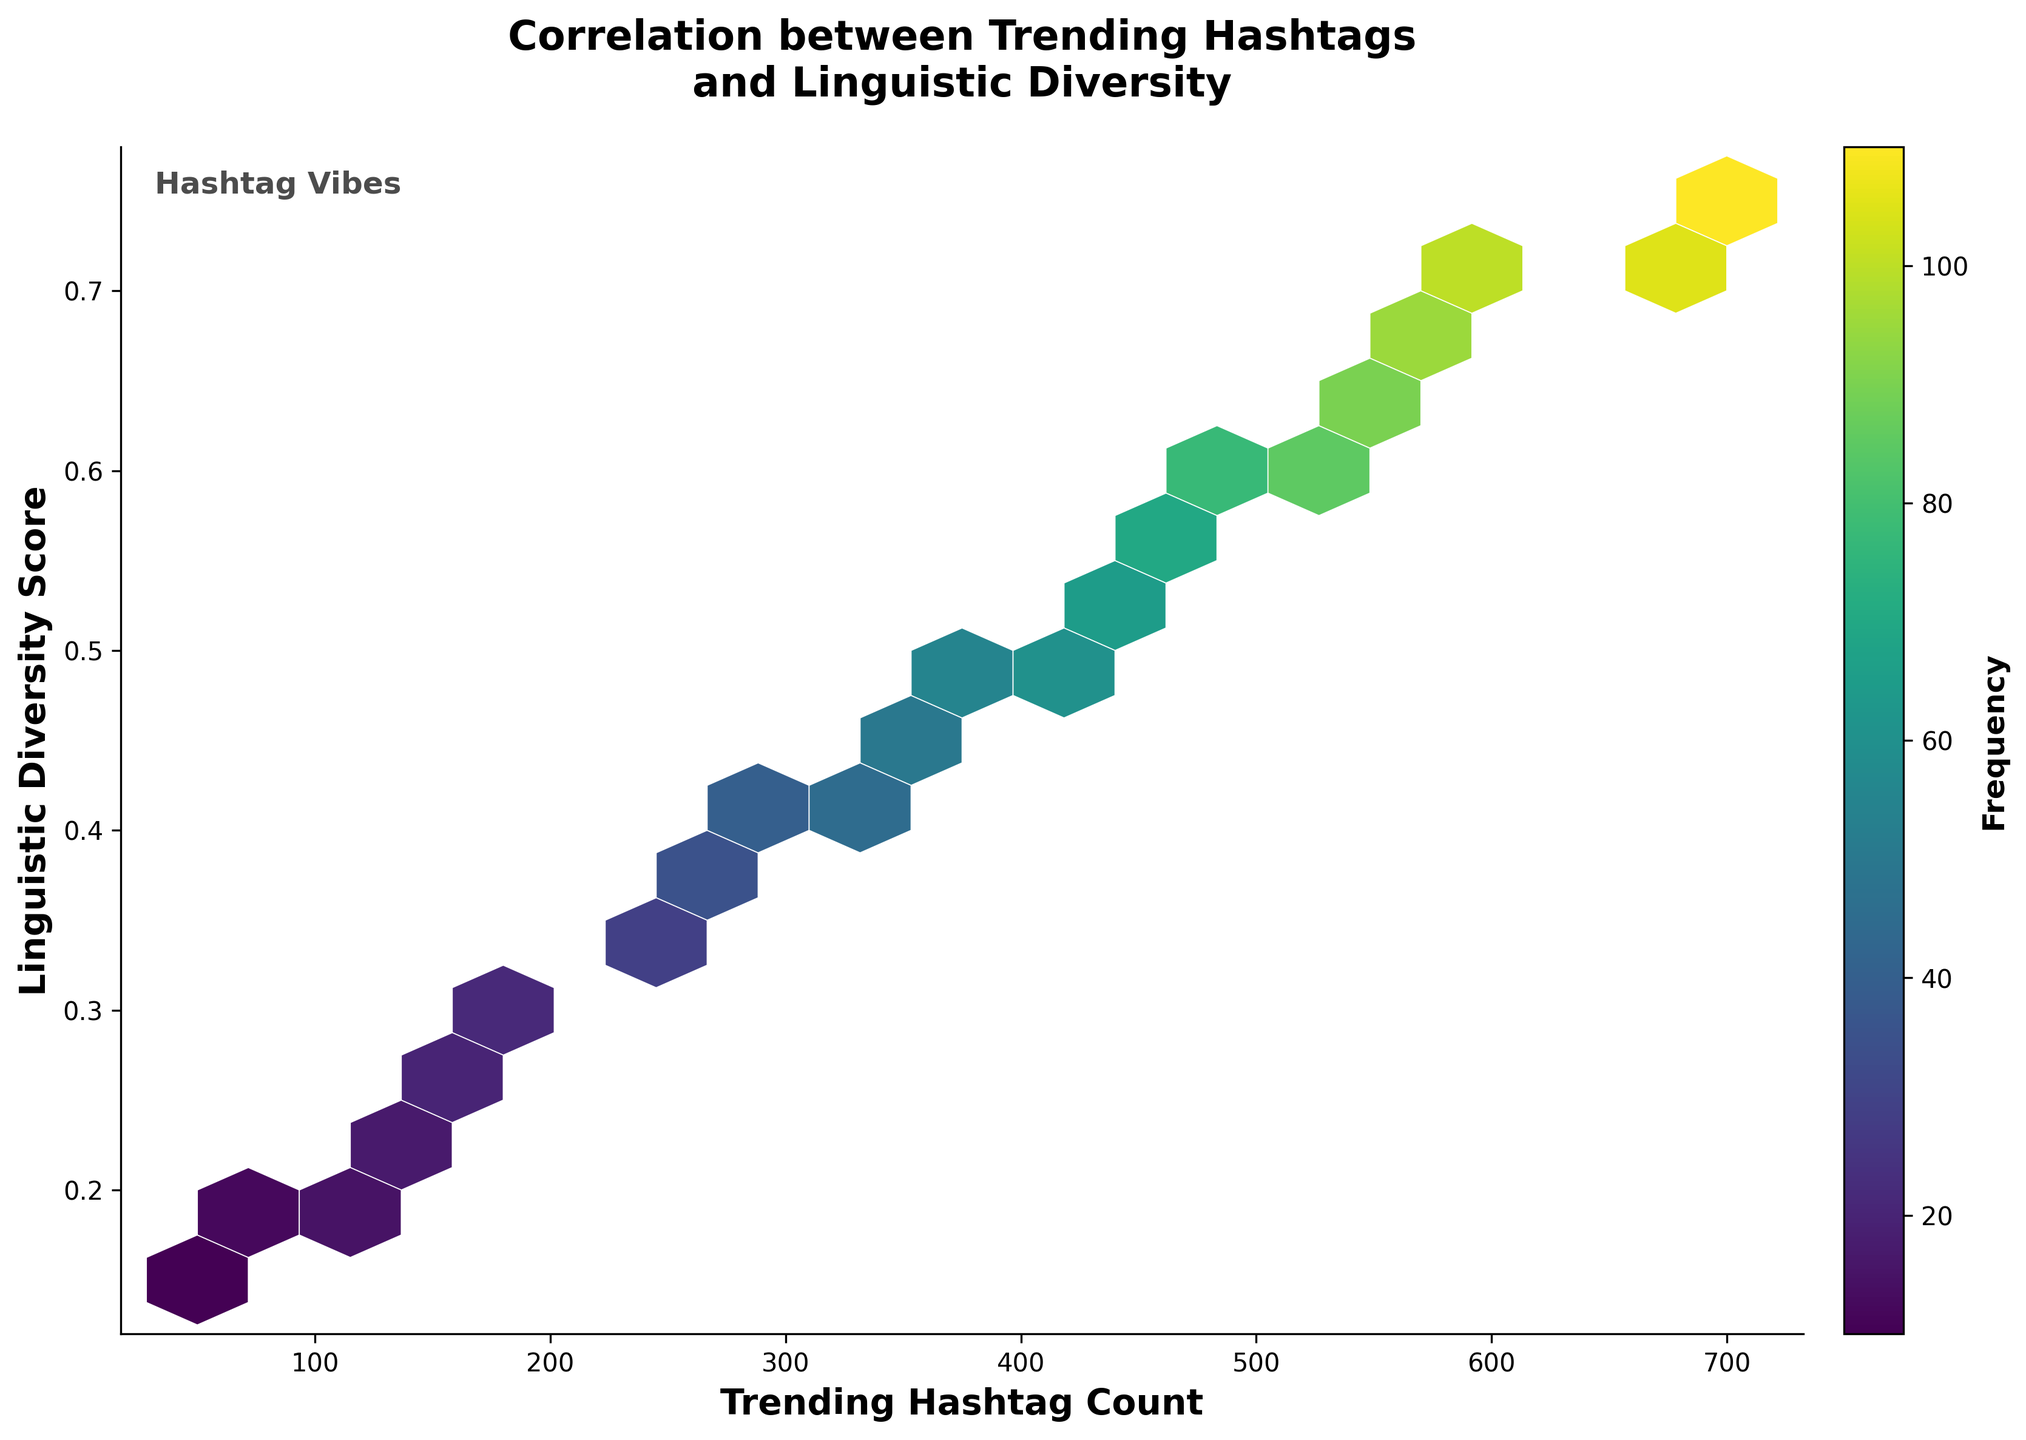what is the title of the plot? The title is prominently displayed at the top of the chart. It is centered and uses bold text in a larger font.
Answer: Correlation between Trending Hashtags and Linguistic Diversity what is the label of the x-axis? The label for the x-axis can be found below the x-axis, written in bold text.
Answer: Trending Hashtag Count how many hexagons are present in the plot? By visually counting the discrete hexagons filled with color on the plot, one can determine the number of hexagons. The hexagons are tessellated without overlapping.
Answer: 15 what color represents the highest frequency? The color bar on the side of the plot indicates that the color with the highest value is the most intense. The frequencies are represented by colors ranging from light to dark shades.
Answer: Dark purple what does the color bar on the right represent? The color bar provides a reference for understanding the frequency indicated by the colors within the hexagons in the plot. Higher frequency corresponds to darker colors.
Answer: Frequency what is the linguistic diversity score corresponding to the hashtag count of around 350? Locate the hexagon around the x-axis value of 350 and check its corresponding y-axis value to find the linguistic diversity score.
Answer: Approximately 0.45 is there a general trend between trending hashtag count and linguistic diversity score? By observing the overall distribution and the directionality of the hexagons from lower counts to higher counts, one can discern the general trend. The hexagons generally show a positive slope indicating that higher hashtag counts tend to have higher linguistic diversity scores.
Answer: Positive correlation which point has the highest frequency, and what is its linguistic diversity score? Locate the hexagon with the darkest color representing the highest frequency, then check the corresponding y-axis value to find the linguistic diversity score.
Answer: 110, 0.75 compare the frequencies of the hashtags count of 300 and 700, which is more frequent? Look at the respective hexagons at x-values of 300 and 700, then compare the colors or refer directly to the frequency values if marked.
Answer: 700 how does the linguistic diversity score vary with a hashtag count between 100 and 200? Observe the hexagons in the range between 100 and 200 on the x-axis, and note how the y-values (linguistic diversity scores) change within this range.
Answer: Increases from 0.2 to 0.3 